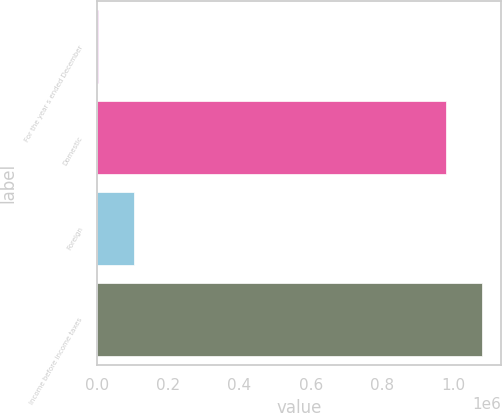Convert chart. <chart><loc_0><loc_0><loc_500><loc_500><bar_chart><fcel>For the year s ended December<fcel>Domestic<fcel>Foreign<fcel>Income before income taxes<nl><fcel>2012<fcel>980176<fcel>103369<fcel>1.08153e+06<nl></chart> 